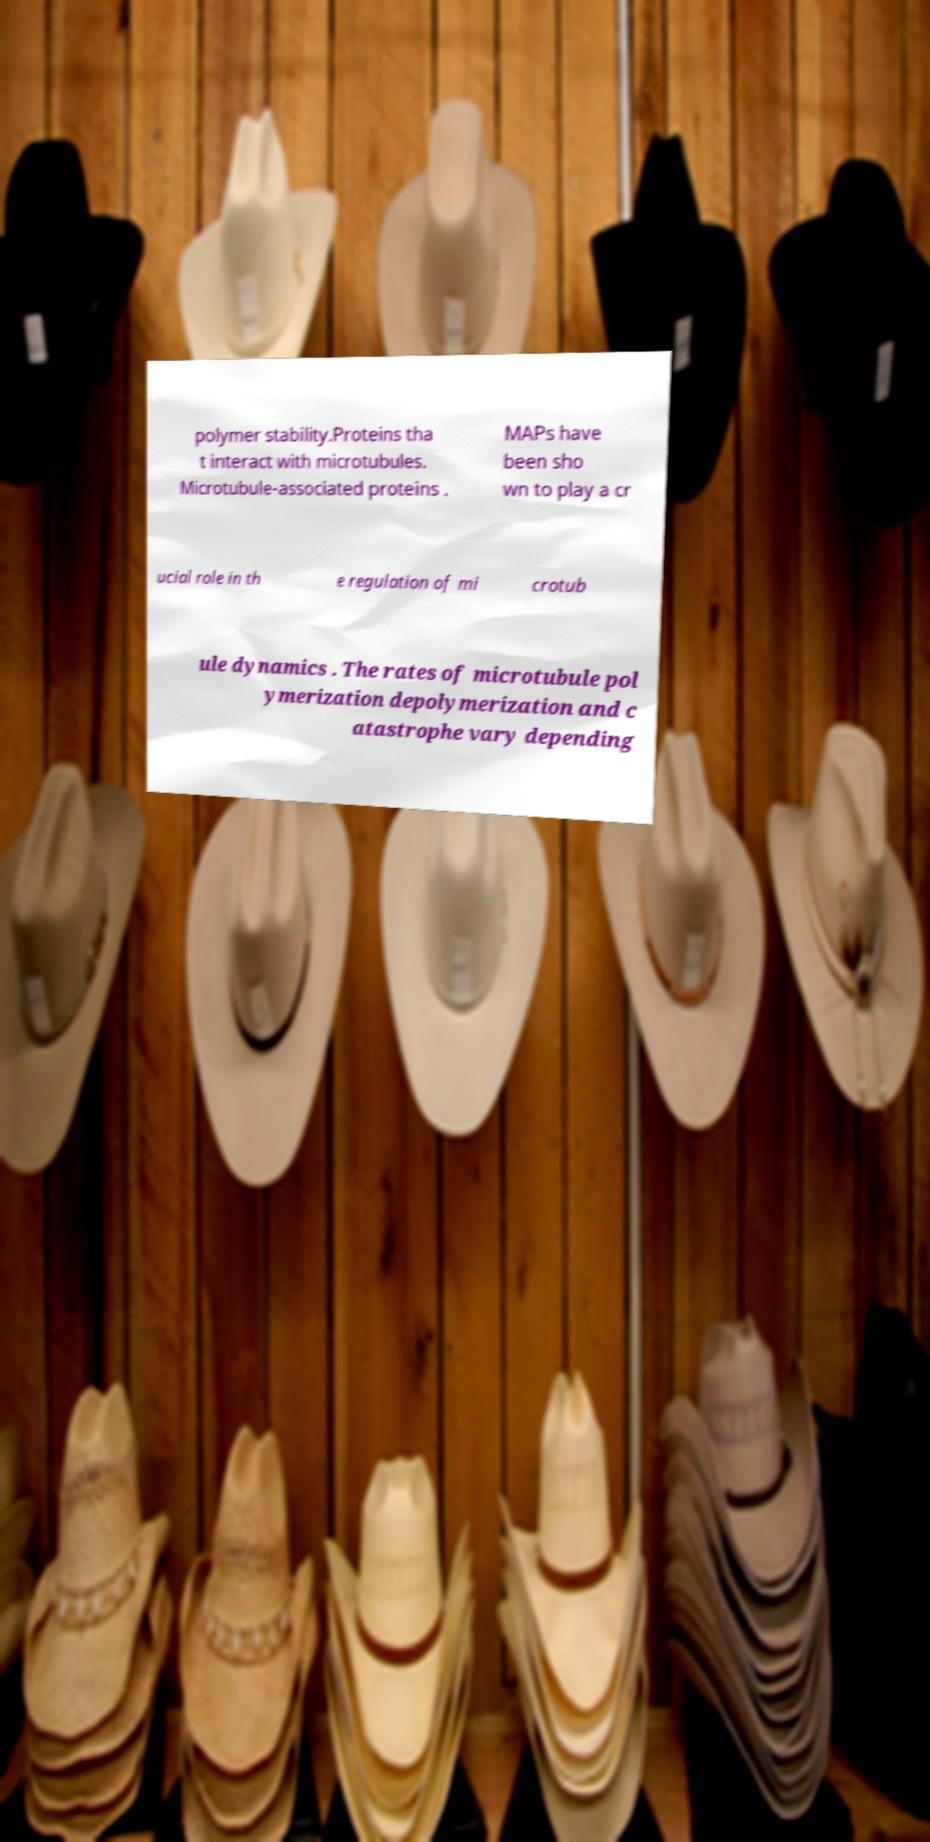Please read and relay the text visible in this image. What does it say? polymer stability.Proteins tha t interact with microtubules. Microtubule-associated proteins . MAPs have been sho wn to play a cr ucial role in th e regulation of mi crotub ule dynamics . The rates of microtubule pol ymerization depolymerization and c atastrophe vary depending 